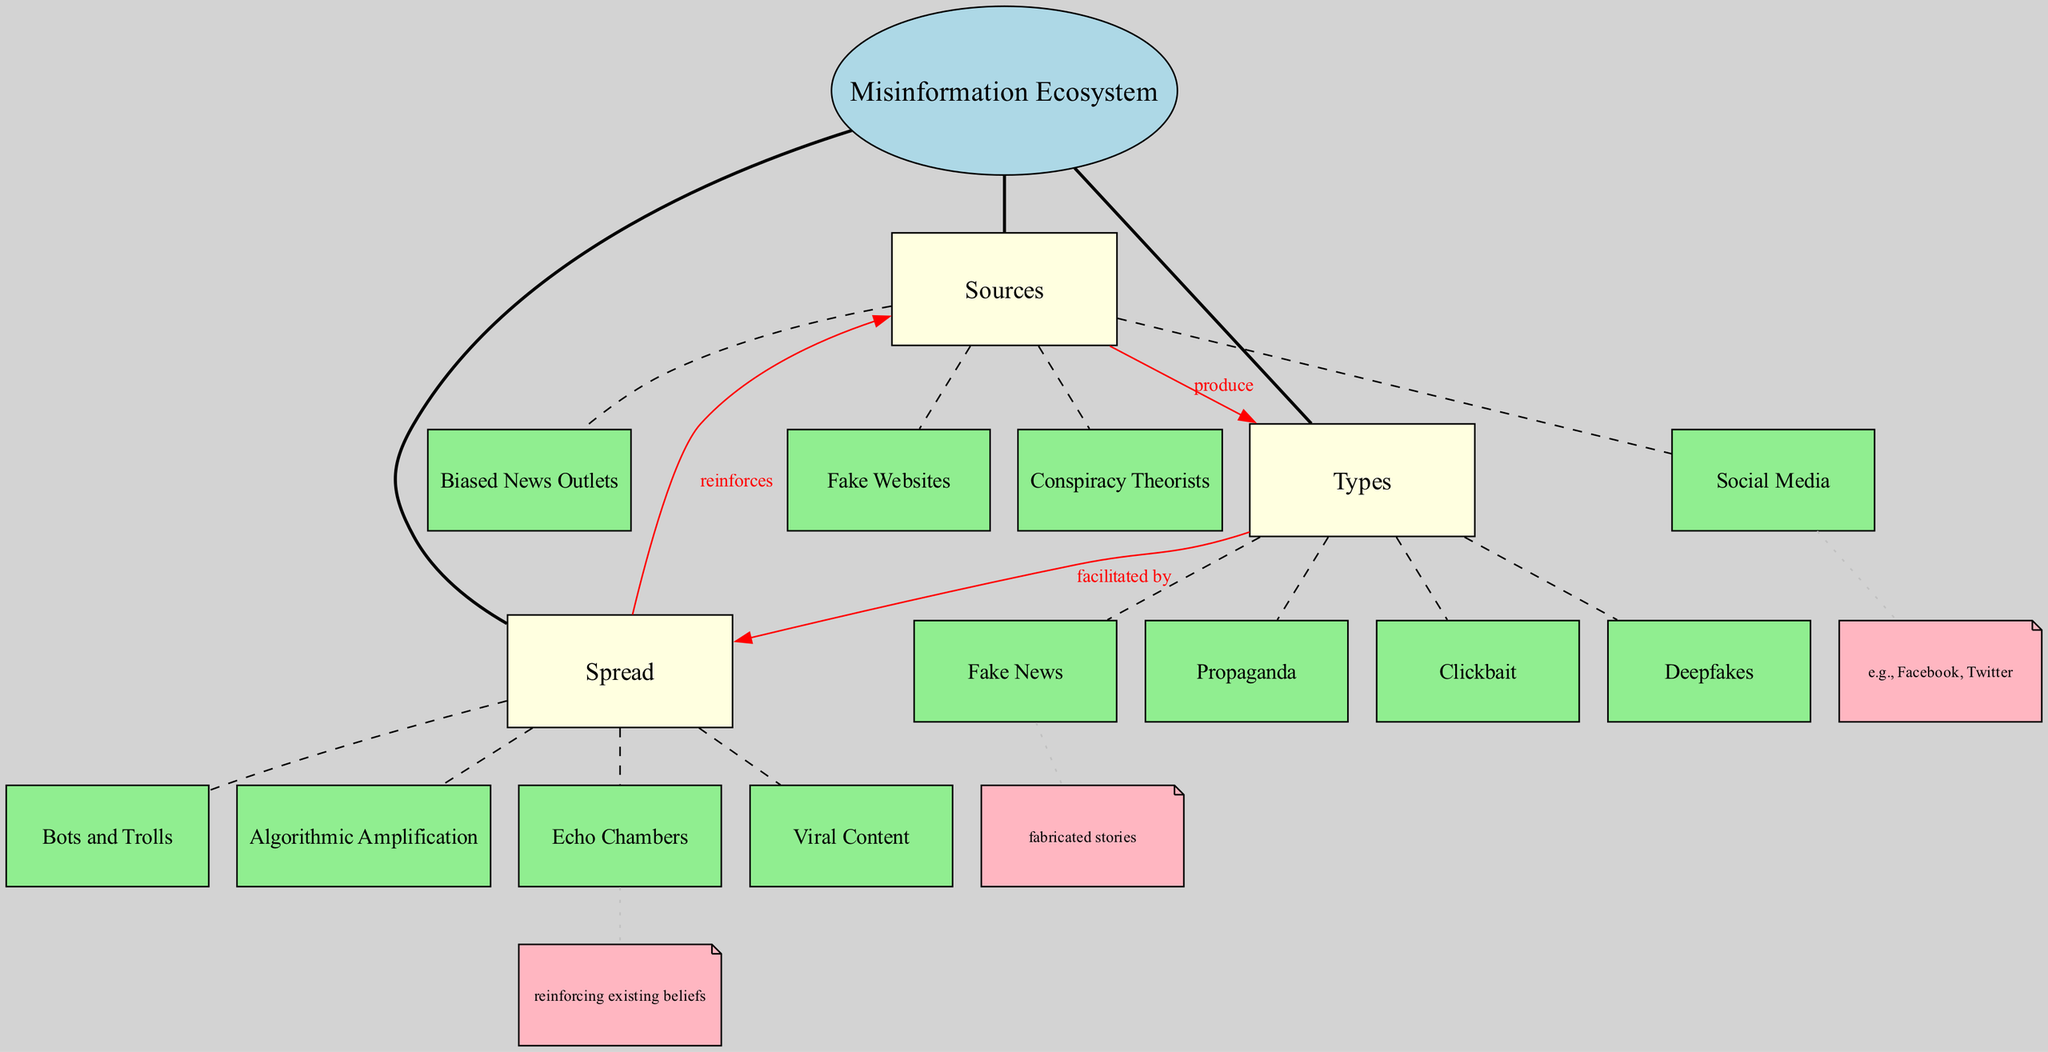What is the central concept of the diagram? The diagram highlights the central concept named "Misinformation Ecosystem." This is clearly stated at the top of the concept map and is the main focal point for all other nodes connected to it.
Answer: Misinformation Ecosystem How many main nodes are there in the diagram? The diagram includes three main nodes: "Sources," "Types," and "Spread." This can be verified by counting the connections that emanate directly from the central concept.
Answer: 3 Which main node produces "Fake News"? "Sources" is the main node that connects to the type "Fake News," indicating that various sources are responsible for producing this type of misinformation.
Answer: Sources What type of misinformation is facilitated by "Viral Content"? "Types" connects to "Spread," showing that the type of misinformation that is facilitated by the item "Viral Content" is connected to the flow of information in the diagram. Specifically, "Fake News," "Propaganda," "Clickbait," and "Deepfakes" can spread as viral content.
Answer: Fake News, Propaganda, Clickbait, Deepfakes Which source is noted to reinforce the concept of "Echo Chambers"? The diagram illustrates that "Spread" can reinforce the "Sources," which includes "Social Media," reflecting how platforms like these can create echo chambers where misinformation thrives.
Answer: Social Media What is the relationship between "Types" and "Spread"? The relationship is indicated by the label "facilitated by," which explains that the types of misinformation, including "Fake News" and others, are facilitated in their spread by the mechanisms outlined in the "Spread" node.
Answer: facilitated by Which node is considered a biased source? "Biased News Outlets" is highlighted as part of the "Sources" sub-node in the diagram, clearly categorizing it as a source of misinformation that is influenced by specific biases.
Answer: Biased News Outlets How does "Algorithmic Amplification" relate to "Spread"? The "Spread" node includes "Algorithmic Amplification," which indicates that this process is one of the ways in which misinformation can become more widespread, showing a connection between algorithms and the distribution of false information.
Answer: Algorithmic Amplification Which type of misinformation includes fabricated stories? The type "Fake News" is defined in the diagram as including fabricated stories, which is noted in the additional information section connected to this node.
Answer: Fake News 